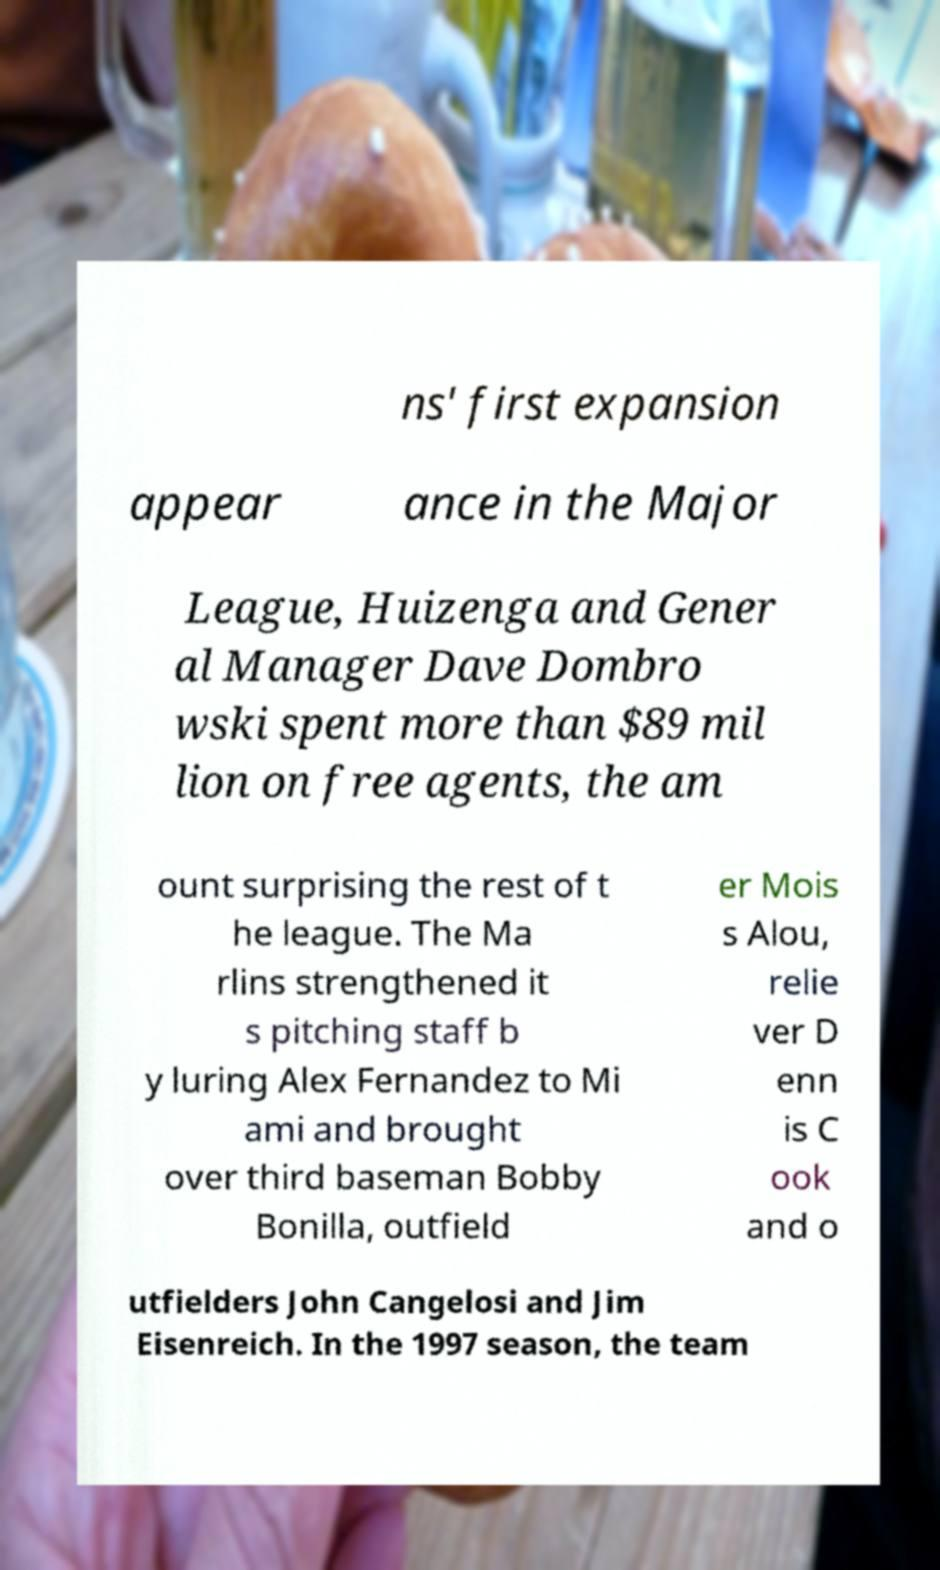Please identify and transcribe the text found in this image. ns' first expansion appear ance in the Major League, Huizenga and Gener al Manager Dave Dombro wski spent more than $89 mil lion on free agents, the am ount surprising the rest of t he league. The Ma rlins strengthened it s pitching staff b y luring Alex Fernandez to Mi ami and brought over third baseman Bobby Bonilla, outfield er Mois s Alou, relie ver D enn is C ook and o utfielders John Cangelosi and Jim Eisenreich. In the 1997 season, the team 